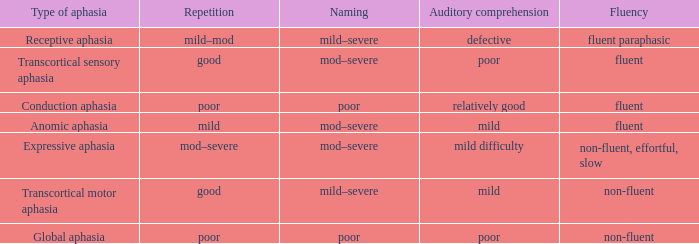Write the full table. {'header': ['Type of aphasia', 'Repetition', 'Naming', 'Auditory comprehension', 'Fluency'], 'rows': [['Receptive aphasia', 'mild–mod', 'mild–severe', 'defective', 'fluent paraphasic'], ['Transcortical sensory aphasia', 'good', 'mod–severe', 'poor', 'fluent'], ['Conduction aphasia', 'poor', 'poor', 'relatively good', 'fluent'], ['Anomic aphasia', 'mild', 'mod–severe', 'mild', 'fluent'], ['Expressive aphasia', 'mod–severe', 'mod–severe', 'mild difficulty', 'non-fluent, effortful, slow'], ['Transcortical motor aphasia', 'good', 'mild–severe', 'mild', 'non-fluent'], ['Global aphasia', 'poor', 'poor', 'poor', 'non-fluent']]} Identify the terms for smooth and inadequate comprehension. Mod–severe. 